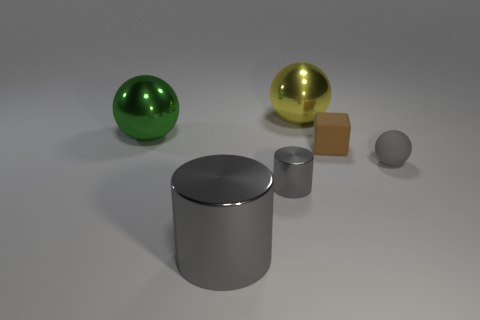Subtract all big metal spheres. How many spheres are left? 1 Subtract 1 balls. How many balls are left? 2 Add 3 cylinders. How many objects exist? 9 Subtract all blocks. How many objects are left? 5 Subtract 0 green cubes. How many objects are left? 6 Subtract all big yellow objects. Subtract all big yellow objects. How many objects are left? 4 Add 4 tiny cylinders. How many tiny cylinders are left? 5 Add 1 tiny gray cylinders. How many tiny gray cylinders exist? 2 